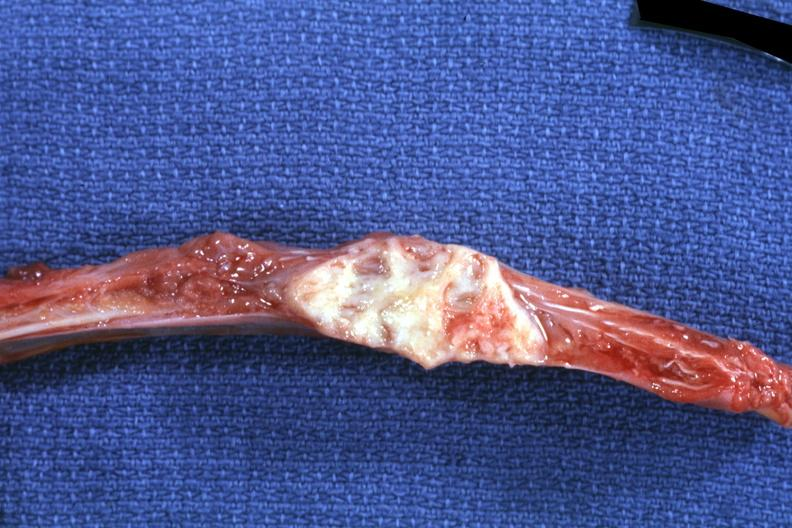what is present?
Answer the question using a single word or phrase. Joints 